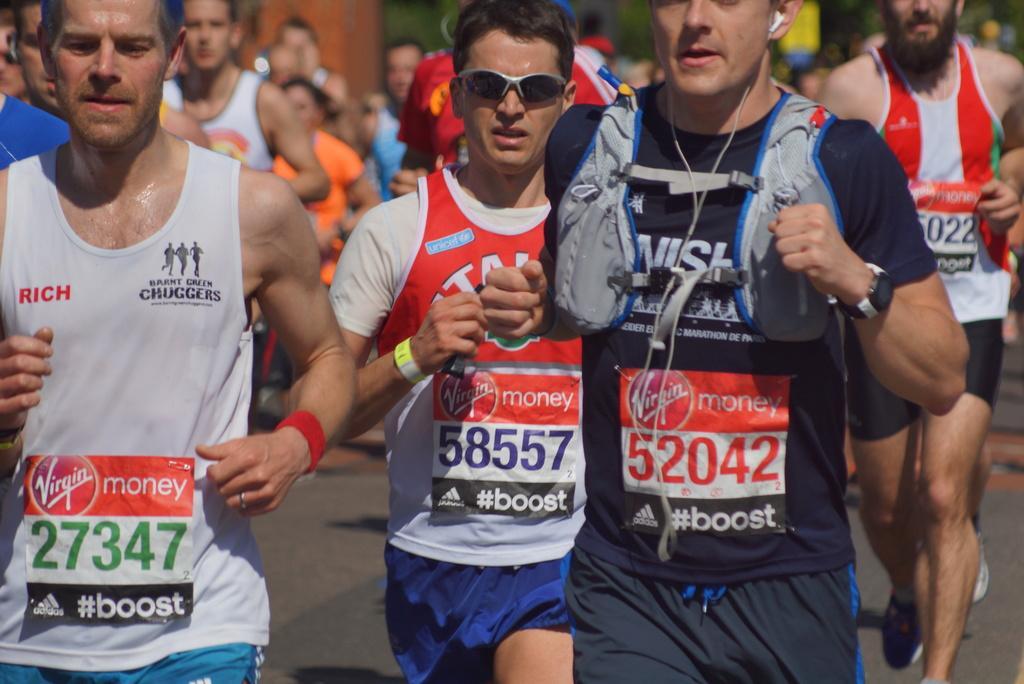Describe this image in one or two sentences. There are many people running. Person on the right is wearing a watch and a headphones. Also he is having a jacket. Middle person is wearing a goggles and a wrist watch. They are having chest numbers. 